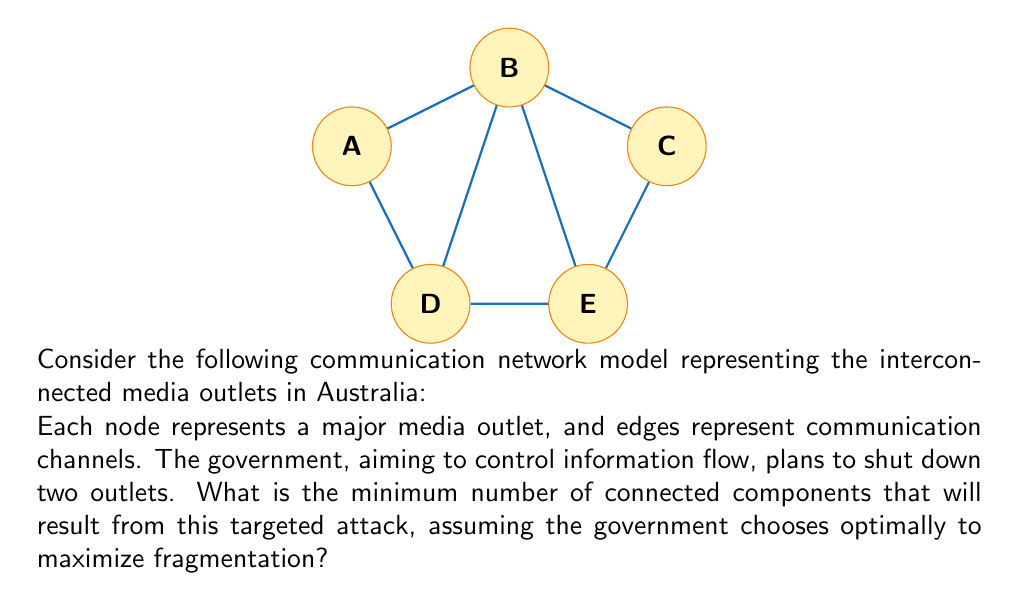Can you solve this math problem? To solve this problem, we need to analyze the graph's structure and determine the most effective nodes to remove:

1) First, observe that the graph has 5 nodes and 7 edges, forming a connected component.

2) To maximize fragmentation, we need to remove nodes that will disconnect the graph into the most components.

3) Let's examine each node:
   - Node A: Degree 2
   - Node B: Degree 4 (highest degree)
   - Node C: Degree 2
   - Node D: Degree 3
   - Node E: Degree 3

4) Removing node B will have the most significant impact as it's connected to all other nodes except C.

5) After removing B, we're left with:
   A--D--E--C

6) To further fragment this, we should remove either D or E.

7) Removing either D or E will result in 3 separate components:
   {A}, {C}, and either {D} or {E}

Therefore, by removing B and either D or E, the government can maximize fragmentation, resulting in 3 separate components.

This analysis reveals how centralized media networks can be vulnerable to targeted attacks, a point that a skeptical journalist might find particularly relevant in critiquing the current media landscape.
Answer: 3 components 